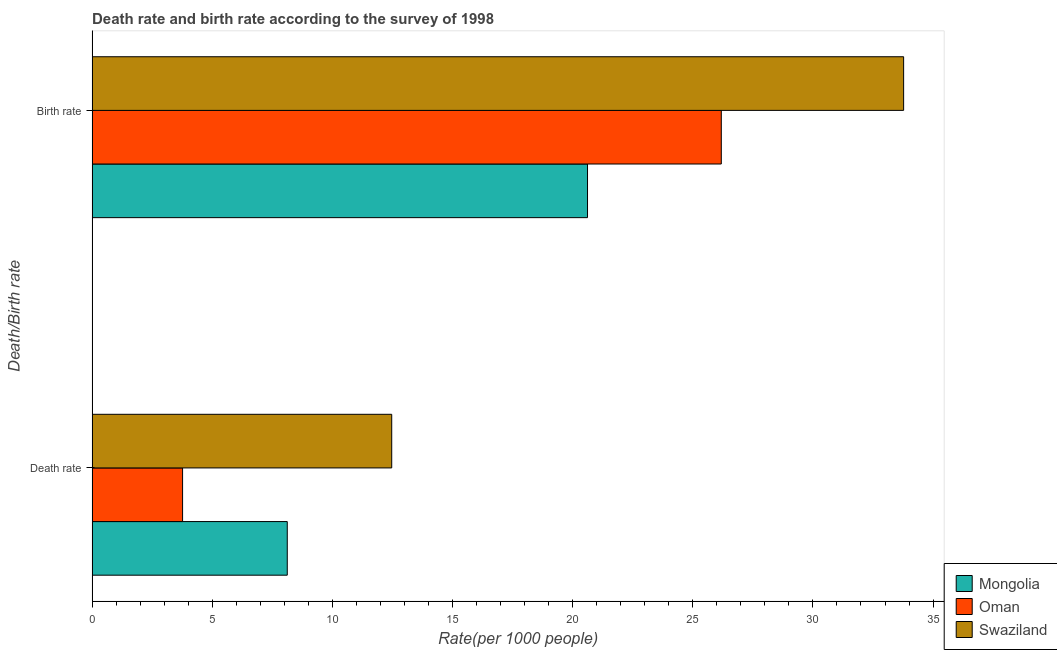How many groups of bars are there?
Ensure brevity in your answer.  2. How many bars are there on the 2nd tick from the top?
Provide a short and direct response. 3. What is the label of the 1st group of bars from the top?
Your answer should be very brief. Birth rate. What is the death rate in Oman?
Provide a succinct answer. 3.77. Across all countries, what is the maximum birth rate?
Offer a terse response. 33.77. Across all countries, what is the minimum death rate?
Give a very brief answer. 3.77. In which country was the birth rate maximum?
Your response must be concise. Swaziland. In which country was the death rate minimum?
Provide a succinct answer. Oman. What is the total birth rate in the graph?
Make the answer very short. 80.58. What is the difference between the birth rate in Mongolia and that in Oman?
Make the answer very short. -5.57. What is the difference between the birth rate in Oman and the death rate in Mongolia?
Offer a very short reply. 18.06. What is the average birth rate per country?
Keep it short and to the point. 26.86. What is the difference between the death rate and birth rate in Swaziland?
Provide a short and direct response. -21.3. In how many countries, is the birth rate greater than 32 ?
Your answer should be very brief. 1. What is the ratio of the death rate in Swaziland to that in Mongolia?
Make the answer very short. 1.54. Is the birth rate in Swaziland less than that in Mongolia?
Offer a very short reply. No. What does the 2nd bar from the top in Death rate represents?
Make the answer very short. Oman. What does the 3rd bar from the bottom in Death rate represents?
Your answer should be compact. Swaziland. What is the difference between two consecutive major ticks on the X-axis?
Provide a succinct answer. 5. Are the values on the major ticks of X-axis written in scientific E-notation?
Keep it short and to the point. No. Where does the legend appear in the graph?
Make the answer very short. Bottom right. What is the title of the graph?
Give a very brief answer. Death rate and birth rate according to the survey of 1998. What is the label or title of the X-axis?
Give a very brief answer. Rate(per 1000 people). What is the label or title of the Y-axis?
Provide a succinct answer. Death/Birth rate. What is the Rate(per 1000 people) of Mongolia in Death rate?
Ensure brevity in your answer.  8.12. What is the Rate(per 1000 people) in Oman in Death rate?
Ensure brevity in your answer.  3.77. What is the Rate(per 1000 people) in Swaziland in Death rate?
Make the answer very short. 12.47. What is the Rate(per 1000 people) of Mongolia in Birth rate?
Your answer should be compact. 20.62. What is the Rate(per 1000 people) of Oman in Birth rate?
Give a very brief answer. 26.19. What is the Rate(per 1000 people) of Swaziland in Birth rate?
Your answer should be compact. 33.77. Across all Death/Birth rate, what is the maximum Rate(per 1000 people) in Mongolia?
Keep it short and to the point. 20.62. Across all Death/Birth rate, what is the maximum Rate(per 1000 people) of Oman?
Make the answer very short. 26.19. Across all Death/Birth rate, what is the maximum Rate(per 1000 people) in Swaziland?
Ensure brevity in your answer.  33.77. Across all Death/Birth rate, what is the minimum Rate(per 1000 people) of Mongolia?
Provide a succinct answer. 8.12. Across all Death/Birth rate, what is the minimum Rate(per 1000 people) in Oman?
Your answer should be compact. 3.77. Across all Death/Birth rate, what is the minimum Rate(per 1000 people) of Swaziland?
Give a very brief answer. 12.47. What is the total Rate(per 1000 people) in Mongolia in the graph?
Provide a short and direct response. 28.74. What is the total Rate(per 1000 people) in Oman in the graph?
Provide a short and direct response. 29.95. What is the total Rate(per 1000 people) in Swaziland in the graph?
Offer a very short reply. 46.24. What is the difference between the Rate(per 1000 people) in Mongolia in Death rate and that in Birth rate?
Your response must be concise. -12.5. What is the difference between the Rate(per 1000 people) of Oman in Death rate and that in Birth rate?
Your answer should be very brief. -22.42. What is the difference between the Rate(per 1000 people) in Swaziland in Death rate and that in Birth rate?
Provide a succinct answer. -21.3. What is the difference between the Rate(per 1000 people) of Mongolia in Death rate and the Rate(per 1000 people) of Oman in Birth rate?
Keep it short and to the point. -18.06. What is the difference between the Rate(per 1000 people) in Mongolia in Death rate and the Rate(per 1000 people) in Swaziland in Birth rate?
Give a very brief answer. -25.65. What is the difference between the Rate(per 1000 people) in Oman in Death rate and the Rate(per 1000 people) in Swaziland in Birth rate?
Ensure brevity in your answer.  -30.01. What is the average Rate(per 1000 people) in Mongolia per Death/Birth rate?
Your answer should be compact. 14.37. What is the average Rate(per 1000 people) in Oman per Death/Birth rate?
Your answer should be compact. 14.98. What is the average Rate(per 1000 people) of Swaziland per Death/Birth rate?
Offer a terse response. 23.12. What is the difference between the Rate(per 1000 people) in Mongolia and Rate(per 1000 people) in Oman in Death rate?
Make the answer very short. 4.36. What is the difference between the Rate(per 1000 people) in Mongolia and Rate(per 1000 people) in Swaziland in Death rate?
Keep it short and to the point. -4.35. What is the difference between the Rate(per 1000 people) of Oman and Rate(per 1000 people) of Swaziland in Death rate?
Provide a short and direct response. -8.7. What is the difference between the Rate(per 1000 people) in Mongolia and Rate(per 1000 people) in Oman in Birth rate?
Offer a terse response. -5.57. What is the difference between the Rate(per 1000 people) of Mongolia and Rate(per 1000 people) of Swaziland in Birth rate?
Give a very brief answer. -13.16. What is the difference between the Rate(per 1000 people) in Oman and Rate(per 1000 people) in Swaziland in Birth rate?
Offer a terse response. -7.59. What is the ratio of the Rate(per 1000 people) of Mongolia in Death rate to that in Birth rate?
Your response must be concise. 0.39. What is the ratio of the Rate(per 1000 people) in Oman in Death rate to that in Birth rate?
Your response must be concise. 0.14. What is the ratio of the Rate(per 1000 people) of Swaziland in Death rate to that in Birth rate?
Provide a succinct answer. 0.37. What is the difference between the highest and the second highest Rate(per 1000 people) of Mongolia?
Provide a short and direct response. 12.5. What is the difference between the highest and the second highest Rate(per 1000 people) of Oman?
Ensure brevity in your answer.  22.42. What is the difference between the highest and the second highest Rate(per 1000 people) of Swaziland?
Keep it short and to the point. 21.3. What is the difference between the highest and the lowest Rate(per 1000 people) in Mongolia?
Your answer should be very brief. 12.5. What is the difference between the highest and the lowest Rate(per 1000 people) of Oman?
Give a very brief answer. 22.42. What is the difference between the highest and the lowest Rate(per 1000 people) of Swaziland?
Ensure brevity in your answer.  21.3. 